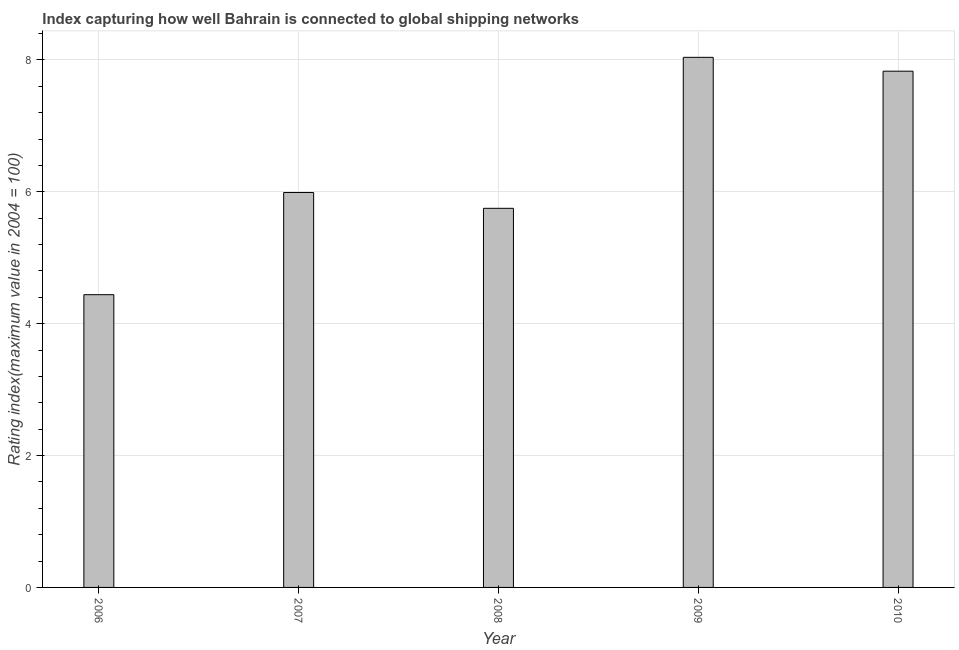Does the graph contain any zero values?
Your response must be concise. No. Does the graph contain grids?
Provide a short and direct response. Yes. What is the title of the graph?
Provide a short and direct response. Index capturing how well Bahrain is connected to global shipping networks. What is the label or title of the Y-axis?
Provide a succinct answer. Rating index(maximum value in 2004 = 100). What is the liner shipping connectivity index in 2008?
Give a very brief answer. 5.75. Across all years, what is the maximum liner shipping connectivity index?
Your answer should be very brief. 8.04. Across all years, what is the minimum liner shipping connectivity index?
Provide a short and direct response. 4.44. What is the sum of the liner shipping connectivity index?
Keep it short and to the point. 32.05. What is the difference between the liner shipping connectivity index in 2006 and 2010?
Keep it short and to the point. -3.39. What is the average liner shipping connectivity index per year?
Make the answer very short. 6.41. What is the median liner shipping connectivity index?
Make the answer very short. 5.99. Do a majority of the years between 2009 and 2007 (inclusive) have liner shipping connectivity index greater than 6 ?
Offer a very short reply. Yes. What is the ratio of the liner shipping connectivity index in 2007 to that in 2008?
Give a very brief answer. 1.04. What is the difference between the highest and the second highest liner shipping connectivity index?
Your answer should be compact. 0.21. Is the sum of the liner shipping connectivity index in 2007 and 2008 greater than the maximum liner shipping connectivity index across all years?
Your answer should be compact. Yes. How many years are there in the graph?
Provide a short and direct response. 5. Are the values on the major ticks of Y-axis written in scientific E-notation?
Offer a very short reply. No. What is the Rating index(maximum value in 2004 = 100) in 2006?
Offer a very short reply. 4.44. What is the Rating index(maximum value in 2004 = 100) in 2007?
Offer a very short reply. 5.99. What is the Rating index(maximum value in 2004 = 100) of 2008?
Make the answer very short. 5.75. What is the Rating index(maximum value in 2004 = 100) of 2009?
Make the answer very short. 8.04. What is the Rating index(maximum value in 2004 = 100) of 2010?
Give a very brief answer. 7.83. What is the difference between the Rating index(maximum value in 2004 = 100) in 2006 and 2007?
Your response must be concise. -1.55. What is the difference between the Rating index(maximum value in 2004 = 100) in 2006 and 2008?
Offer a very short reply. -1.31. What is the difference between the Rating index(maximum value in 2004 = 100) in 2006 and 2009?
Offer a very short reply. -3.6. What is the difference between the Rating index(maximum value in 2004 = 100) in 2006 and 2010?
Make the answer very short. -3.39. What is the difference between the Rating index(maximum value in 2004 = 100) in 2007 and 2008?
Your answer should be compact. 0.24. What is the difference between the Rating index(maximum value in 2004 = 100) in 2007 and 2009?
Make the answer very short. -2.05. What is the difference between the Rating index(maximum value in 2004 = 100) in 2007 and 2010?
Make the answer very short. -1.84. What is the difference between the Rating index(maximum value in 2004 = 100) in 2008 and 2009?
Provide a succinct answer. -2.29. What is the difference between the Rating index(maximum value in 2004 = 100) in 2008 and 2010?
Offer a terse response. -2.08. What is the difference between the Rating index(maximum value in 2004 = 100) in 2009 and 2010?
Your answer should be very brief. 0.21. What is the ratio of the Rating index(maximum value in 2004 = 100) in 2006 to that in 2007?
Make the answer very short. 0.74. What is the ratio of the Rating index(maximum value in 2004 = 100) in 2006 to that in 2008?
Your answer should be compact. 0.77. What is the ratio of the Rating index(maximum value in 2004 = 100) in 2006 to that in 2009?
Give a very brief answer. 0.55. What is the ratio of the Rating index(maximum value in 2004 = 100) in 2006 to that in 2010?
Offer a very short reply. 0.57. What is the ratio of the Rating index(maximum value in 2004 = 100) in 2007 to that in 2008?
Offer a very short reply. 1.04. What is the ratio of the Rating index(maximum value in 2004 = 100) in 2007 to that in 2009?
Provide a succinct answer. 0.74. What is the ratio of the Rating index(maximum value in 2004 = 100) in 2007 to that in 2010?
Ensure brevity in your answer.  0.77. What is the ratio of the Rating index(maximum value in 2004 = 100) in 2008 to that in 2009?
Ensure brevity in your answer.  0.71. What is the ratio of the Rating index(maximum value in 2004 = 100) in 2008 to that in 2010?
Offer a very short reply. 0.73. 